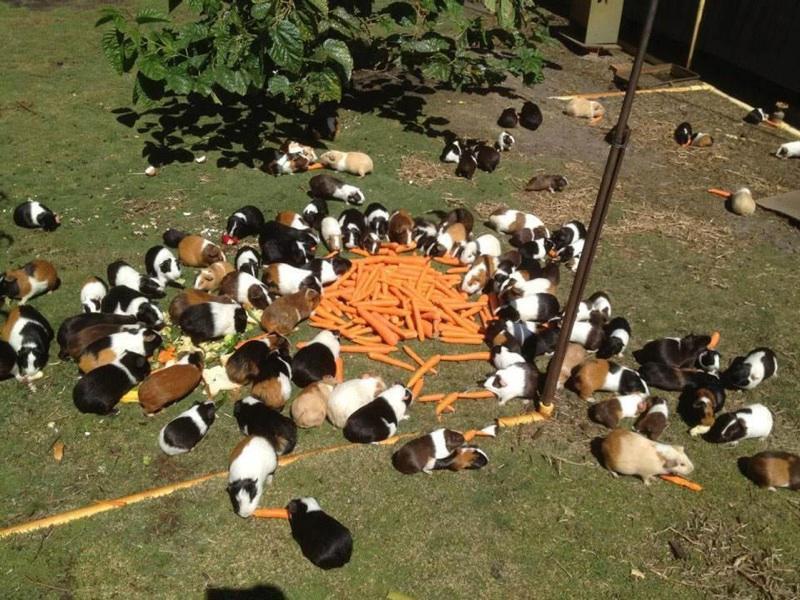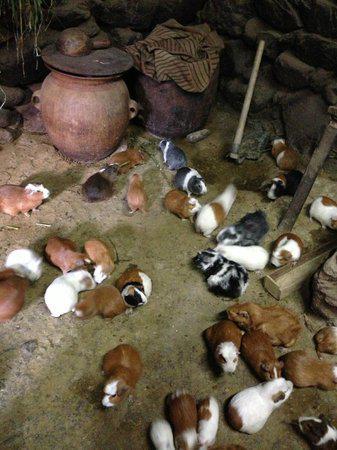The first image is the image on the left, the second image is the image on the right. Assess this claim about the two images: "Guinea pigs are clustered around a pile of vegetables in one photo.". Correct or not? Answer yes or no. Yes. 